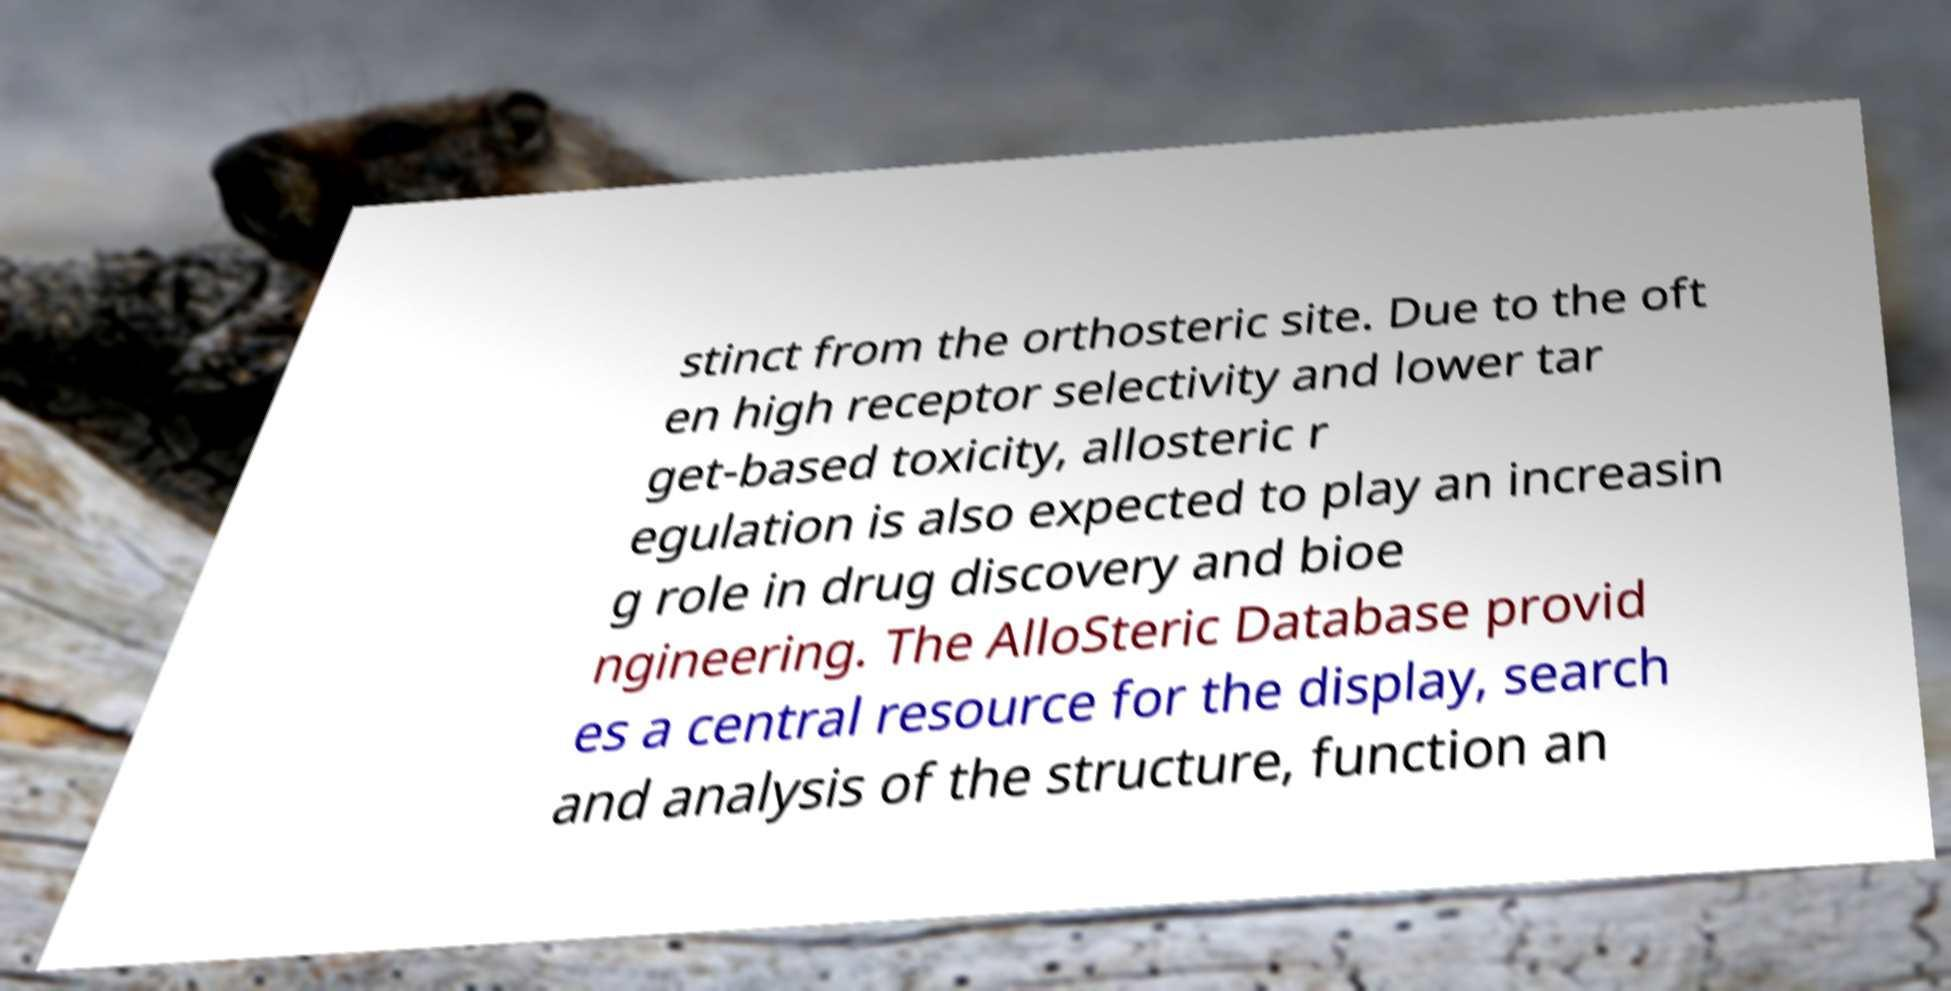Can you accurately transcribe the text from the provided image for me? stinct from the orthosteric site. Due to the oft en high receptor selectivity and lower tar get-based toxicity, allosteric r egulation is also expected to play an increasin g role in drug discovery and bioe ngineering. The AlloSteric Database provid es a central resource for the display, search and analysis of the structure, function an 